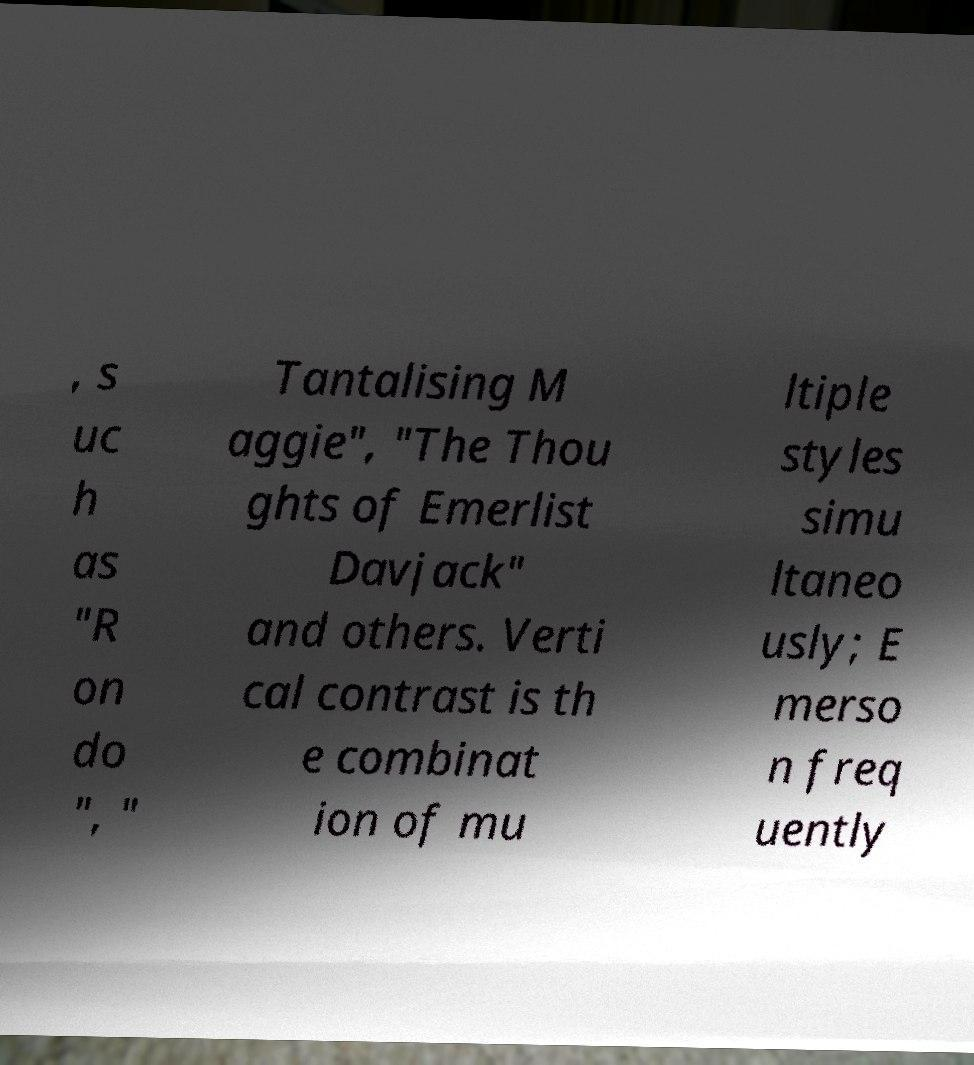There's text embedded in this image that I need extracted. Can you transcribe it verbatim? , s uc h as "R on do ", " Tantalising M aggie", "The Thou ghts of Emerlist Davjack" and others. Verti cal contrast is th e combinat ion of mu ltiple styles simu ltaneo usly; E merso n freq uently 